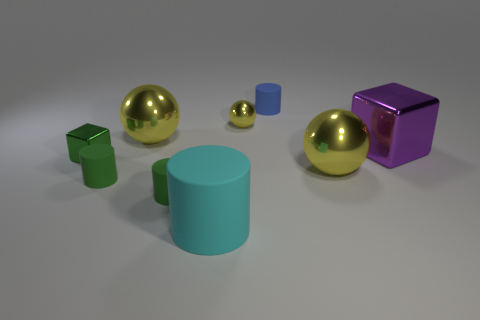Add 1 big balls. How many objects exist? 10 Subtract all cylinders. How many objects are left? 5 Add 2 small metal blocks. How many small metal blocks exist? 3 Subtract 0 gray cylinders. How many objects are left? 9 Subtract all large red shiny objects. Subtract all big purple objects. How many objects are left? 8 Add 3 large spheres. How many large spheres are left? 5 